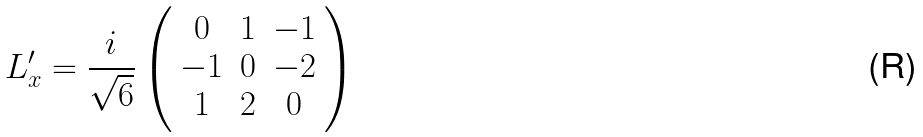Convert formula to latex. <formula><loc_0><loc_0><loc_500><loc_500>L ^ { \prime } _ { x } = \frac { i } { \sqrt { 6 } } \left ( \begin{array} { c c c } 0 & 1 & - 1 \\ - 1 & 0 & - 2 \\ 1 & 2 & 0 \end{array} \right )</formula> 